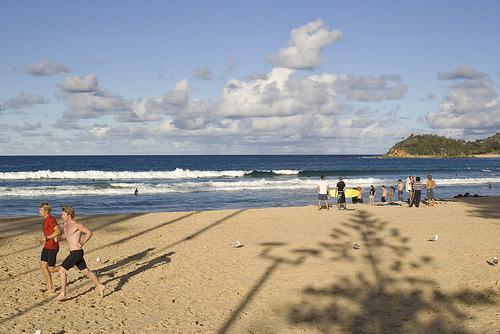How many people are lying on the beach?
Give a very brief answer. 0. 